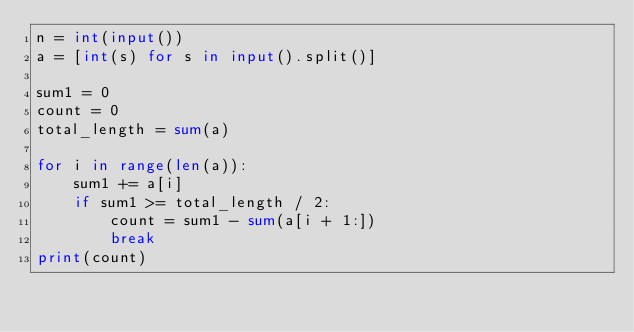<code> <loc_0><loc_0><loc_500><loc_500><_Python_>n = int(input())
a = [int(s) for s in input().split()]

sum1 = 0
count = 0
total_length = sum(a)

for i in range(len(a)):
    sum1 += a[i]
    if sum1 >= total_length / 2:
        count = sum1 - sum(a[i + 1:])
        break
print(count)</code> 